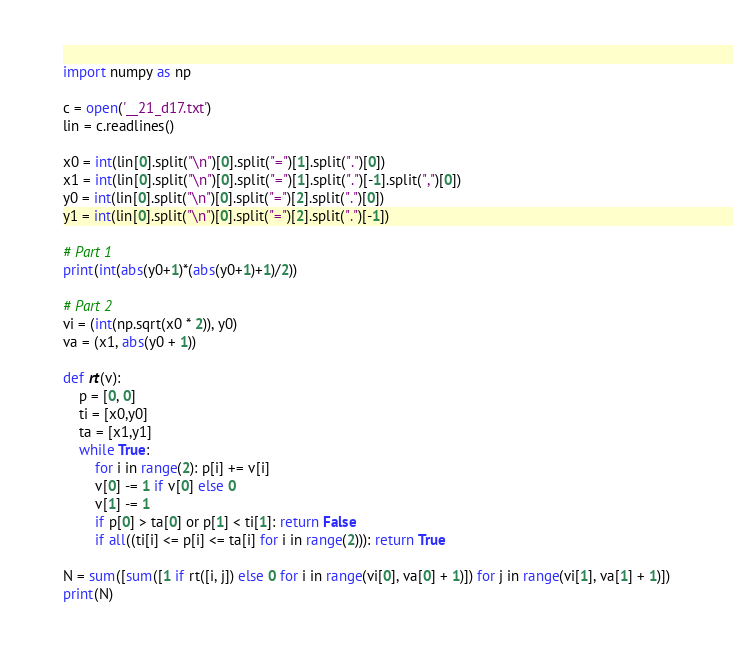Convert code to text. <code><loc_0><loc_0><loc_500><loc_500><_Python_>import numpy as np

c = open('__21_d17.txt')
lin = c.readlines()

x0 = int(lin[0].split("\n")[0].split("=")[1].split(".")[0])
x1 = int(lin[0].split("\n")[0].split("=")[1].split(".")[-1].split(",")[0])
y0 = int(lin[0].split("\n")[0].split("=")[2].split(".")[0])
y1 = int(lin[0].split("\n")[0].split("=")[2].split(".")[-1])

# Part 1
print(int(abs(y0+1)*(abs(y0+1)+1)/2))

# Part 2
vi = (int(np.sqrt(x0 * 2)), y0)
va = (x1, abs(y0 + 1))

def rt(v):
    p = [0, 0]
    ti = [x0,y0]
    ta = [x1,y1]
    while True:
        for i in range(2): p[i] += v[i]
        v[0] -= 1 if v[0] else 0
        v[1] -= 1
        if p[0] > ta[0] or p[1] < ti[1]: return False
        if all((ti[i] <= p[i] <= ta[i] for i in range(2))): return True

N = sum([sum([1 if rt([i, j]) else 0 for i in range(vi[0], va[0] + 1)]) for j in range(vi[1], va[1] + 1)])
print(N)

</code> 